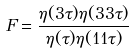Convert formula to latex. <formula><loc_0><loc_0><loc_500><loc_500>F = \frac { \eta ( 3 \tau ) \eta ( 3 3 \tau ) } { \eta ( \tau ) \eta ( 1 1 \tau ) }</formula> 